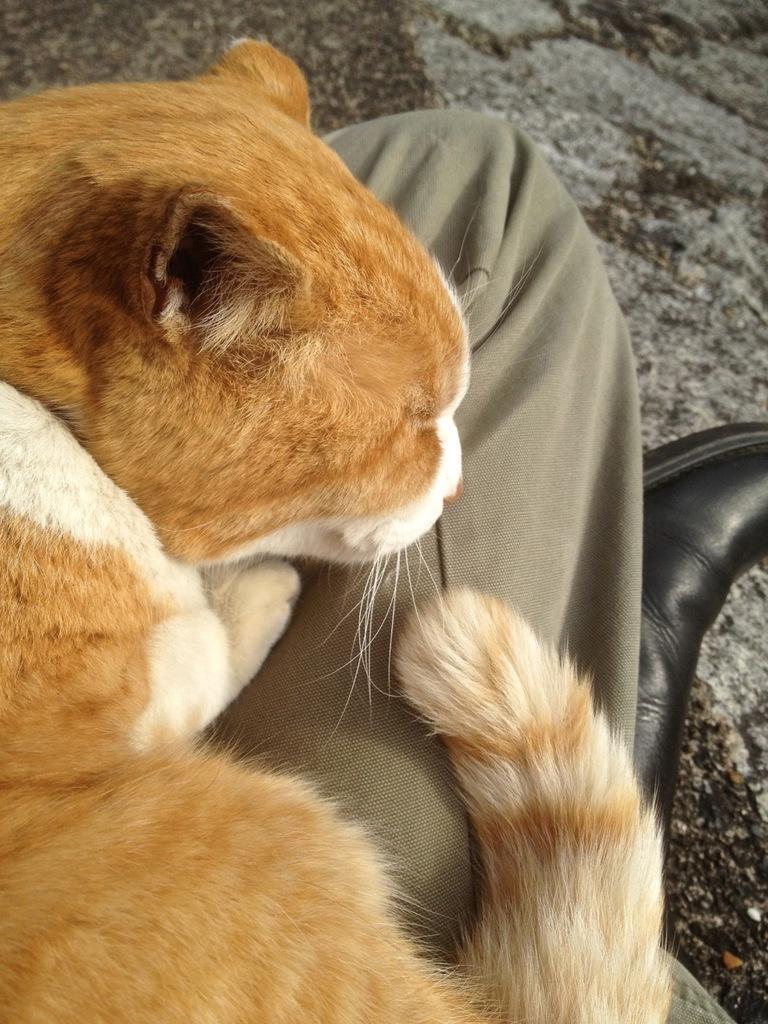Please provide a concise description of this image. In this image I can see a cat which is brown, cream and white in color on person's lap. I can see a black colored shoe and the ground. 